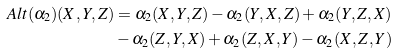Convert formula to latex. <formula><loc_0><loc_0><loc_500><loc_500>A l t ( \alpha _ { 2 } ) ( X , Y , Z ) & = \alpha _ { 2 } ( X , Y , Z ) - \alpha _ { 2 } ( Y , X , Z ) + \alpha _ { 2 } ( Y , Z , X ) \\ & - \alpha _ { 2 } ( Z , Y , X ) + \alpha _ { 2 } ( Z , X , Y ) - \alpha _ { 2 } ( X , Z , Y )</formula> 